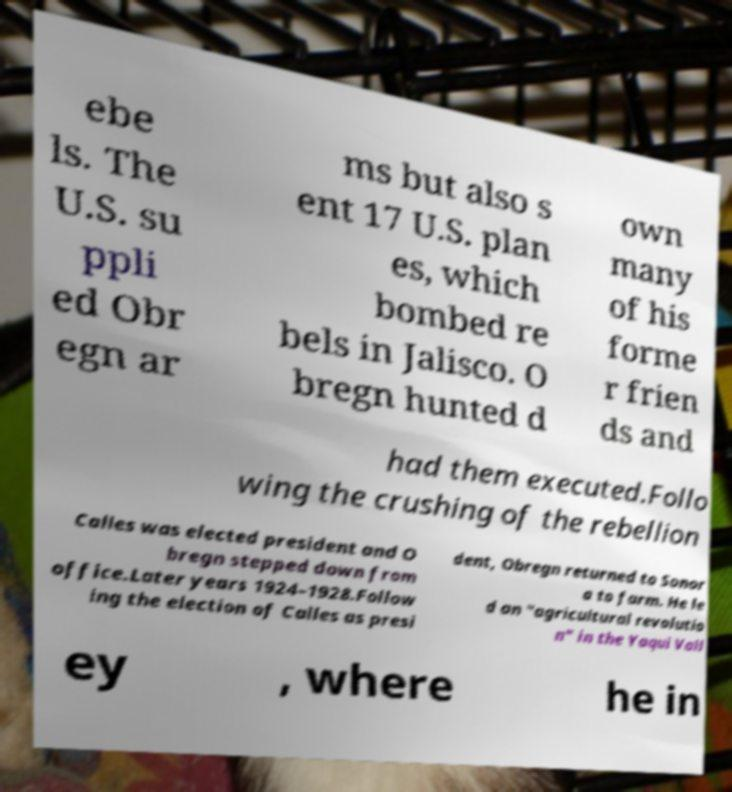There's text embedded in this image that I need extracted. Can you transcribe it verbatim? ebe ls. The U.S. su ppli ed Obr egn ar ms but also s ent 17 U.S. plan es, which bombed re bels in Jalisco. O bregn hunted d own many of his forme r frien ds and had them executed.Follo wing the crushing of the rebellion Calles was elected president and O bregn stepped down from office.Later years 1924–1928.Follow ing the election of Calles as presi dent, Obregn returned to Sonor a to farm. He le d an "agricultural revolutio n" in the Yaqui Vall ey , where he in 